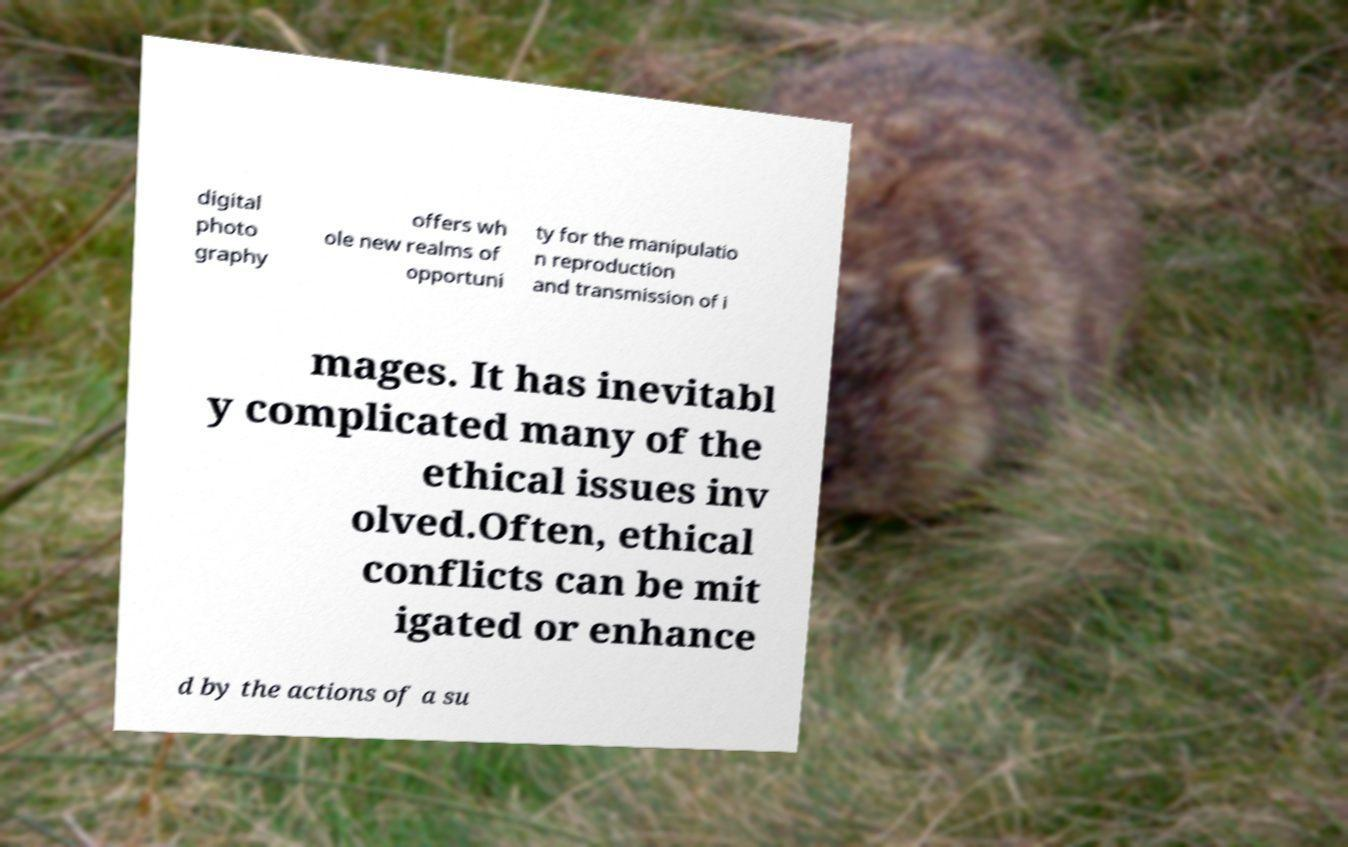Please identify and transcribe the text found in this image. digital photo graphy offers wh ole new realms of opportuni ty for the manipulatio n reproduction and transmission of i mages. It has inevitabl y complicated many of the ethical issues inv olved.Often, ethical conflicts can be mit igated or enhance d by the actions of a su 